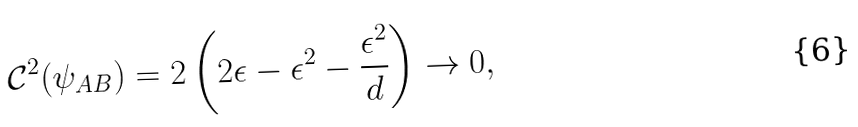<formula> <loc_0><loc_0><loc_500><loc_500>\mathcal { C } ^ { 2 } ( \psi _ { A B } ) = 2 \left ( 2 \epsilon - \epsilon ^ { 2 } - \frac { \epsilon ^ { 2 } } { d } \right ) \rightarrow 0 ,</formula> 